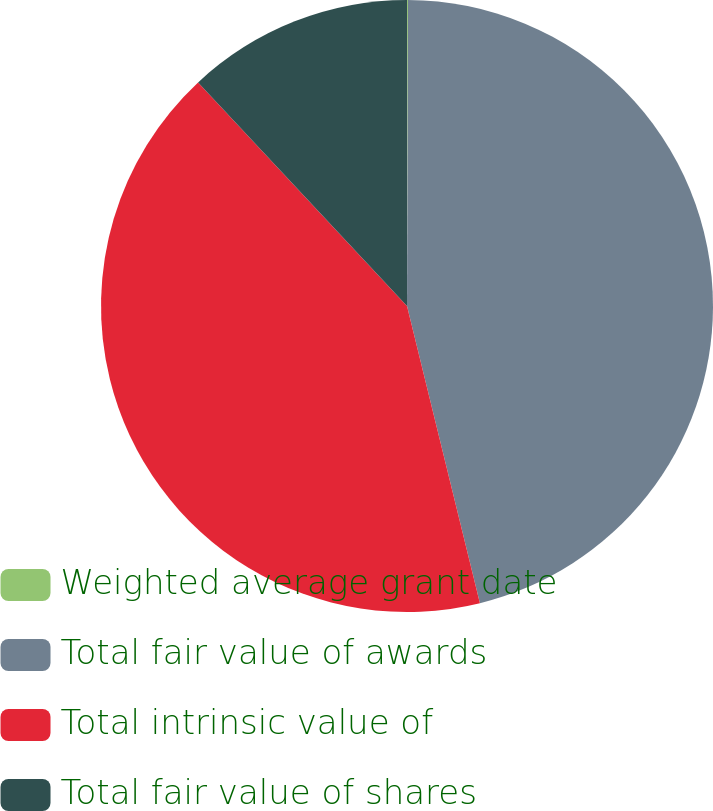Convert chart to OTSL. <chart><loc_0><loc_0><loc_500><loc_500><pie_chart><fcel>Weighted average grant date<fcel>Total fair value of awards<fcel>Total intrinsic value of<fcel>Total fair value of shares<nl><fcel>0.05%<fcel>46.12%<fcel>41.87%<fcel>11.96%<nl></chart> 